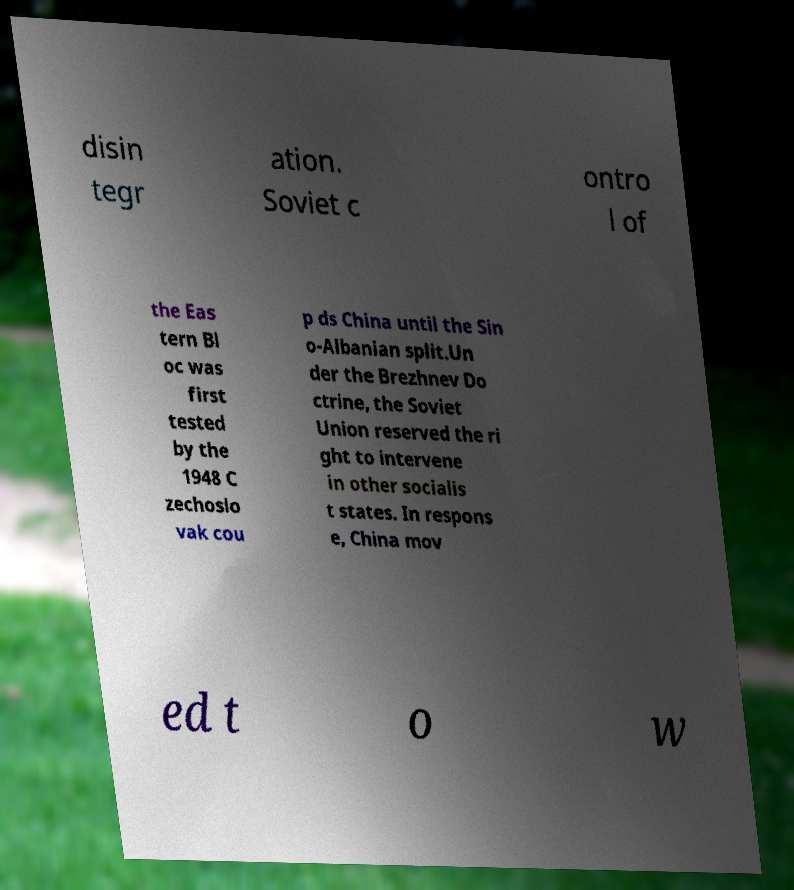I need the written content from this picture converted into text. Can you do that? disin tegr ation. Soviet c ontro l of the Eas tern Bl oc was first tested by the 1948 C zechoslo vak cou p ds China until the Sin o-Albanian split.Un der the Brezhnev Do ctrine, the Soviet Union reserved the ri ght to intervene in other socialis t states. In respons e, China mov ed t o w 